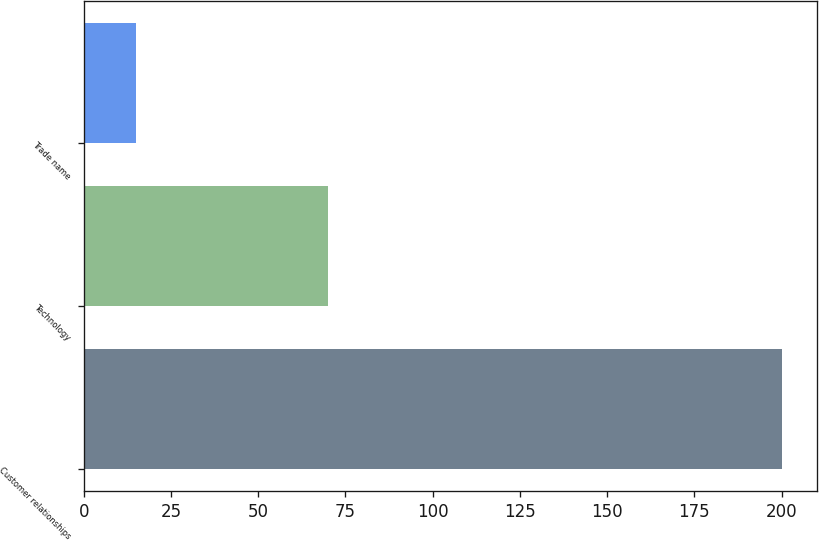Convert chart. <chart><loc_0><loc_0><loc_500><loc_500><bar_chart><fcel>Customer relationships<fcel>Technology<fcel>Trade name<nl><fcel>200<fcel>70<fcel>15<nl></chart> 